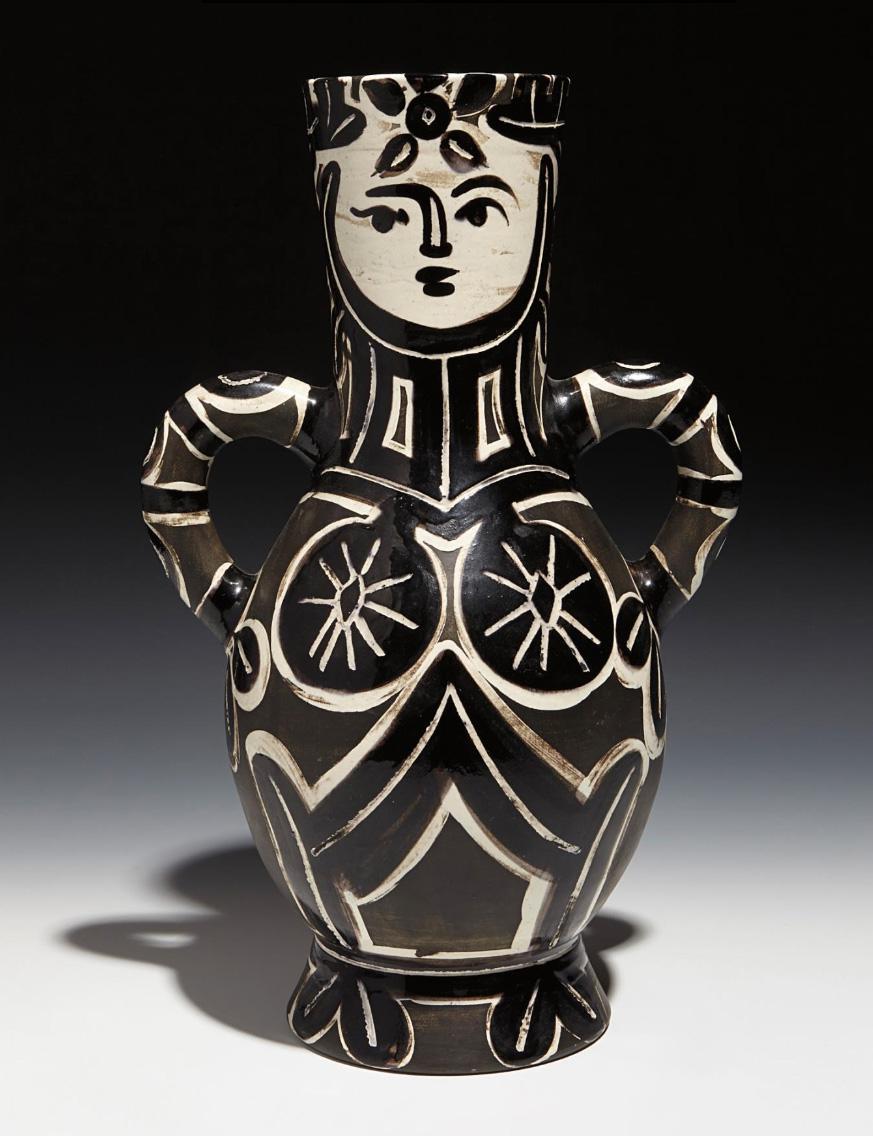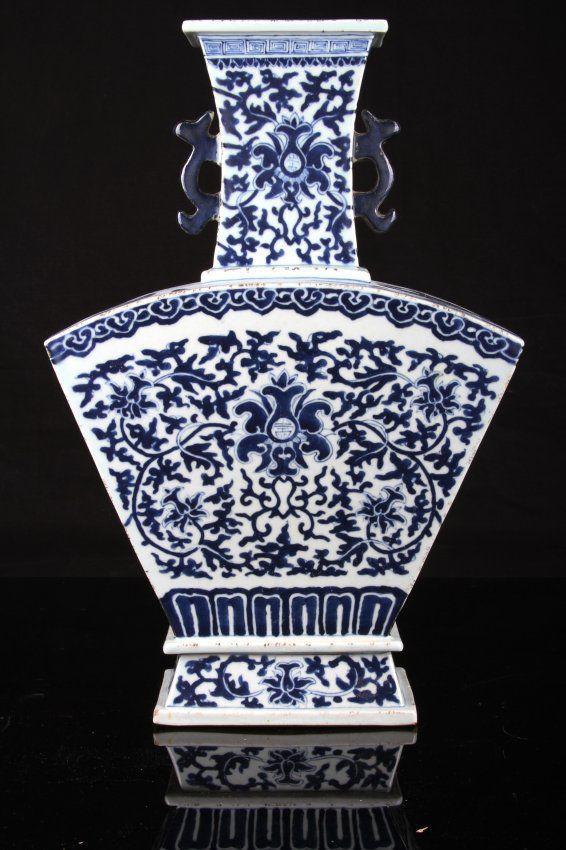The first image is the image on the left, the second image is the image on the right. For the images shown, is this caption "The vase in the image on the left has two handles." true? Answer yes or no. Yes. The first image is the image on the left, the second image is the image on the right. Analyze the images presented: Is the assertion "One vessel has at least one handle, is widest around the middle, and features a stylized depiction of a hooved animal in black." valid? Answer yes or no. No. 